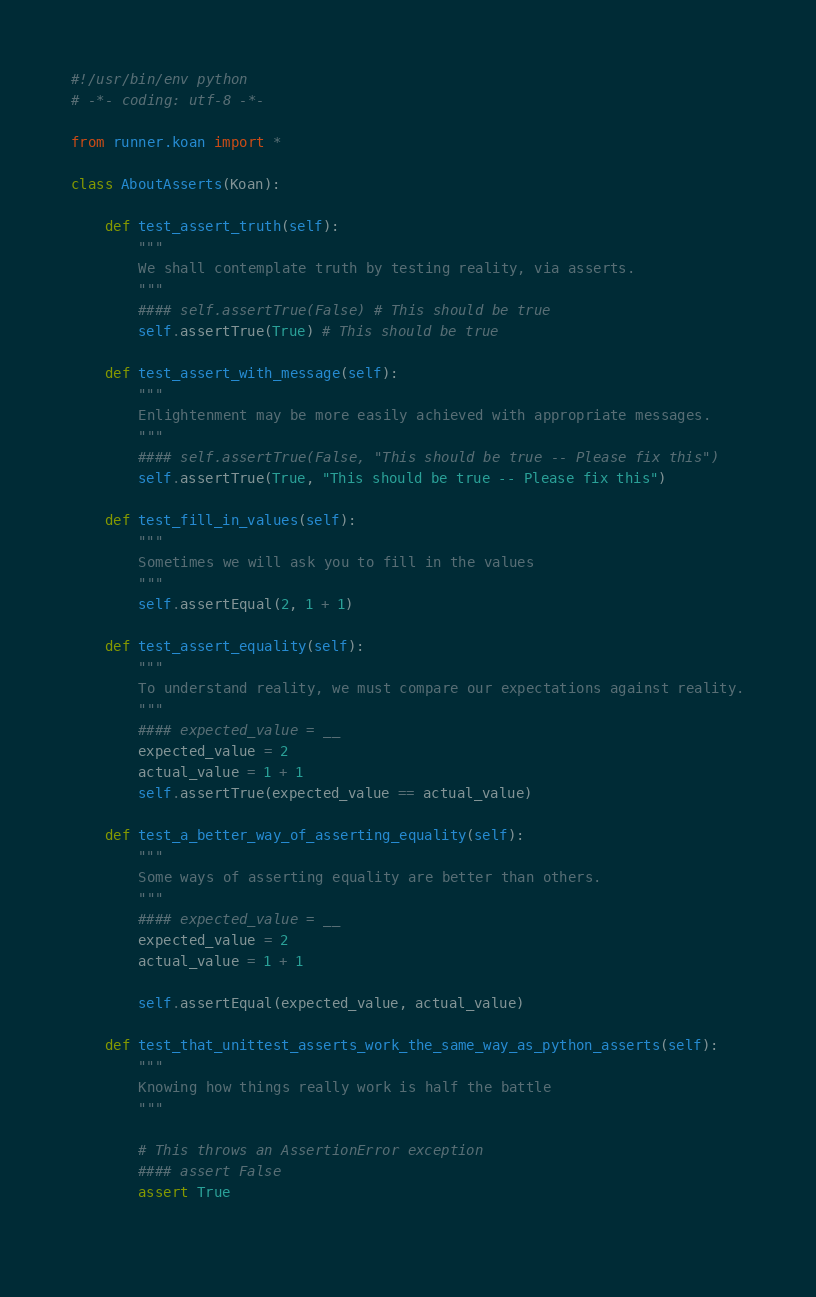Convert code to text. <code><loc_0><loc_0><loc_500><loc_500><_Python_>#!/usr/bin/env python
# -*- coding: utf-8 -*-

from runner.koan import *

class AboutAsserts(Koan):

    def test_assert_truth(self):
        """
        We shall contemplate truth by testing reality, via asserts.
        """
        #### self.assertTrue(False) # This should be true
        self.assertTrue(True) # This should be true
    
    def test_assert_with_message(self):
        """
        Enlightenment may be more easily achieved with appropriate messages.
        """
        #### self.assertTrue(False, "This should be true -- Please fix this")
        self.assertTrue(True, "This should be true -- Please fix this")

    def test_fill_in_values(self):
        """
        Sometimes we will ask you to fill in the values
        """
        self.assertEqual(2, 1 + 1)

    def test_assert_equality(self):
        """
        To understand reality, we must compare our expectations against reality.
        """
        #### expected_value = __
        expected_value = 2
        actual_value = 1 + 1
        self.assertTrue(expected_value == actual_value)

    def test_a_better_way_of_asserting_equality(self):
        """
        Some ways of asserting equality are better than others.
        """
        #### expected_value = __
        expected_value = 2
        actual_value = 1 + 1
        
        self.assertEqual(expected_value, actual_value)
    
    def test_that_unittest_asserts_work_the_same_way_as_python_asserts(self):
        """
        Knowing how things really work is half the battle
        """
        
        # This throws an AssertionError exception
        #### assert False
        assert True
        
</code> 